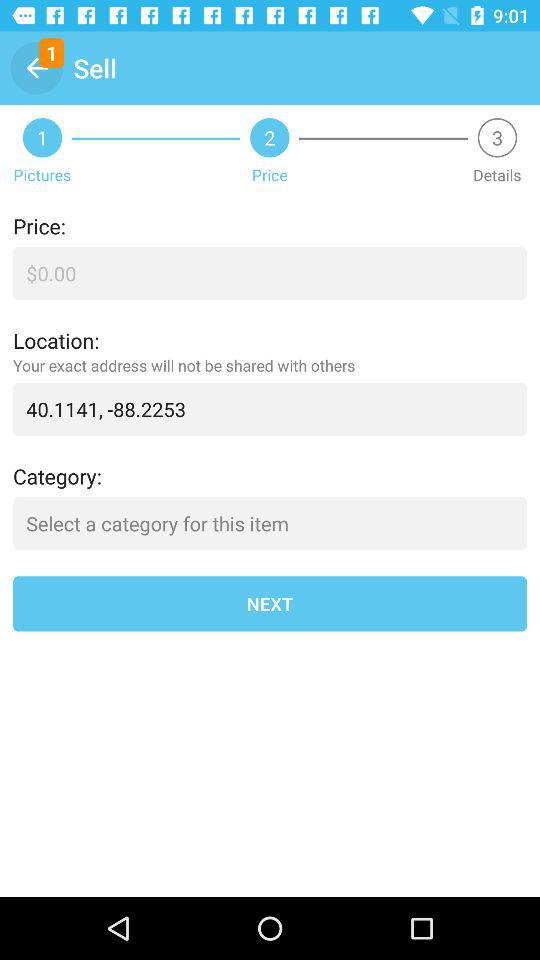Which location is selected? The selected location is 40.1141, -88.2253. 